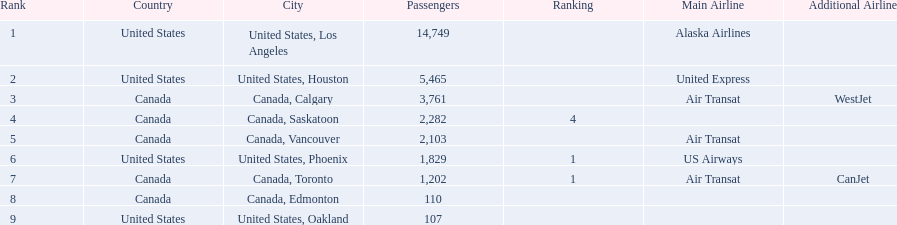Which airport has the least amount of passengers? 107. What airport has 107 passengers? United States, Oakland. 